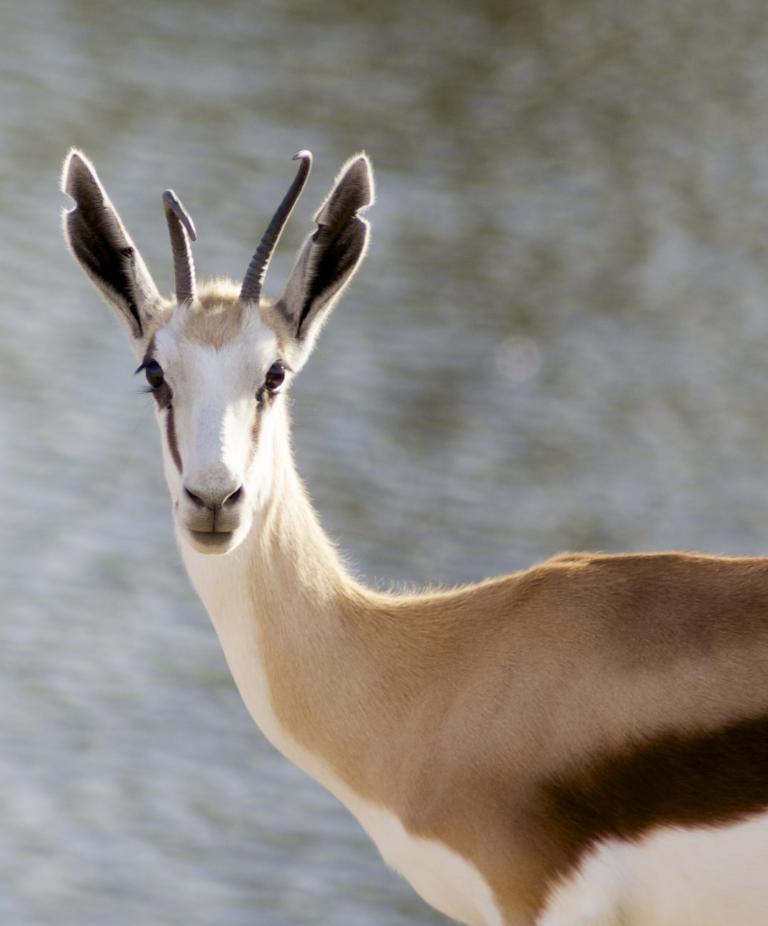How would you summarize this image in a sentence or two? In the center of the image an animal is present. In background the image is blur. 